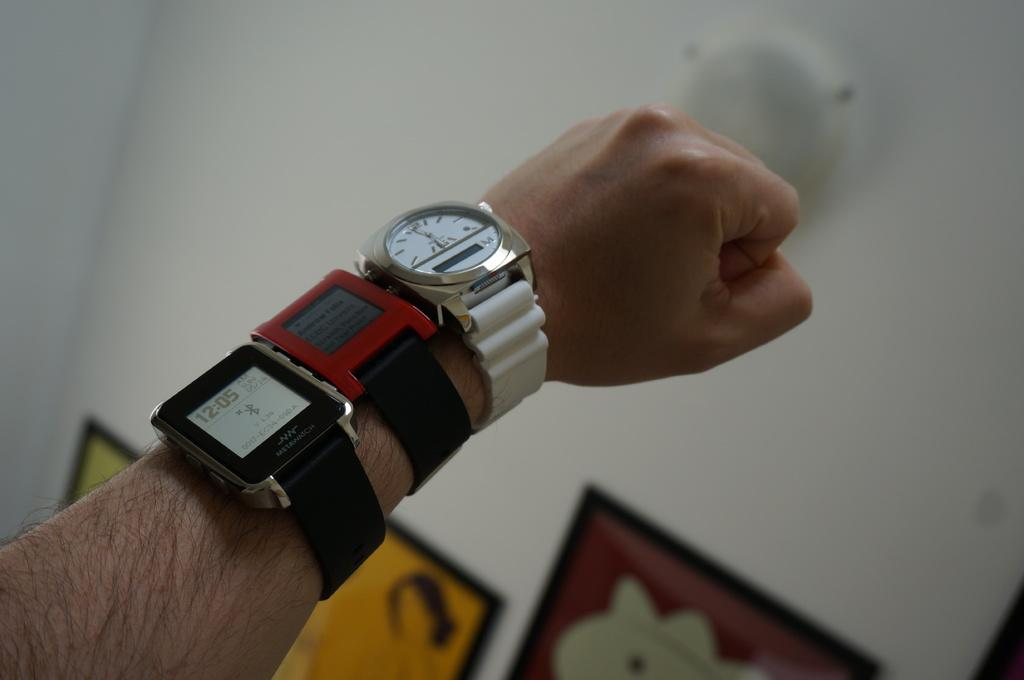Provide a one-sentence caption for the provided image. According to the watch on the man's wrist, it is 12:05. 